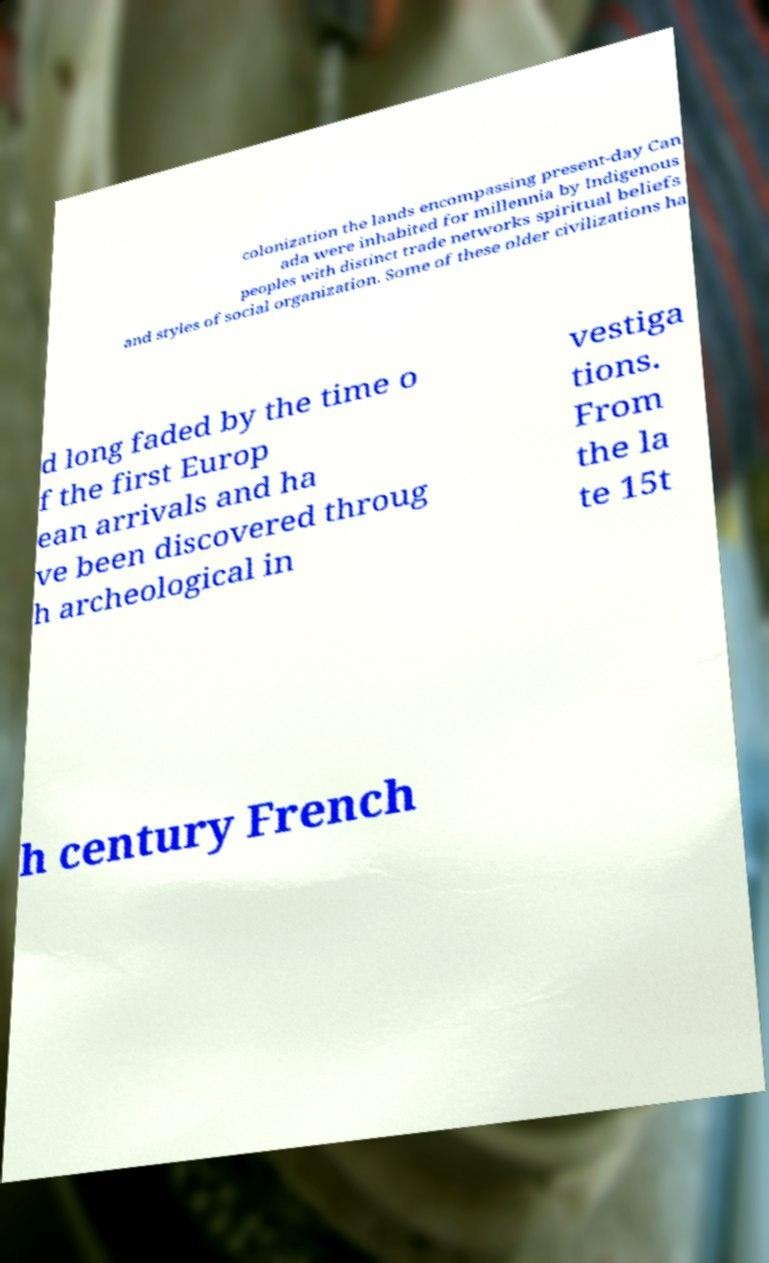Please identify and transcribe the text found in this image. colonization the lands encompassing present-day Can ada were inhabited for millennia by Indigenous peoples with distinct trade networks spiritual beliefs and styles of social organization. Some of these older civilizations ha d long faded by the time o f the first Europ ean arrivals and ha ve been discovered throug h archeological in vestiga tions. From the la te 15t h century French 